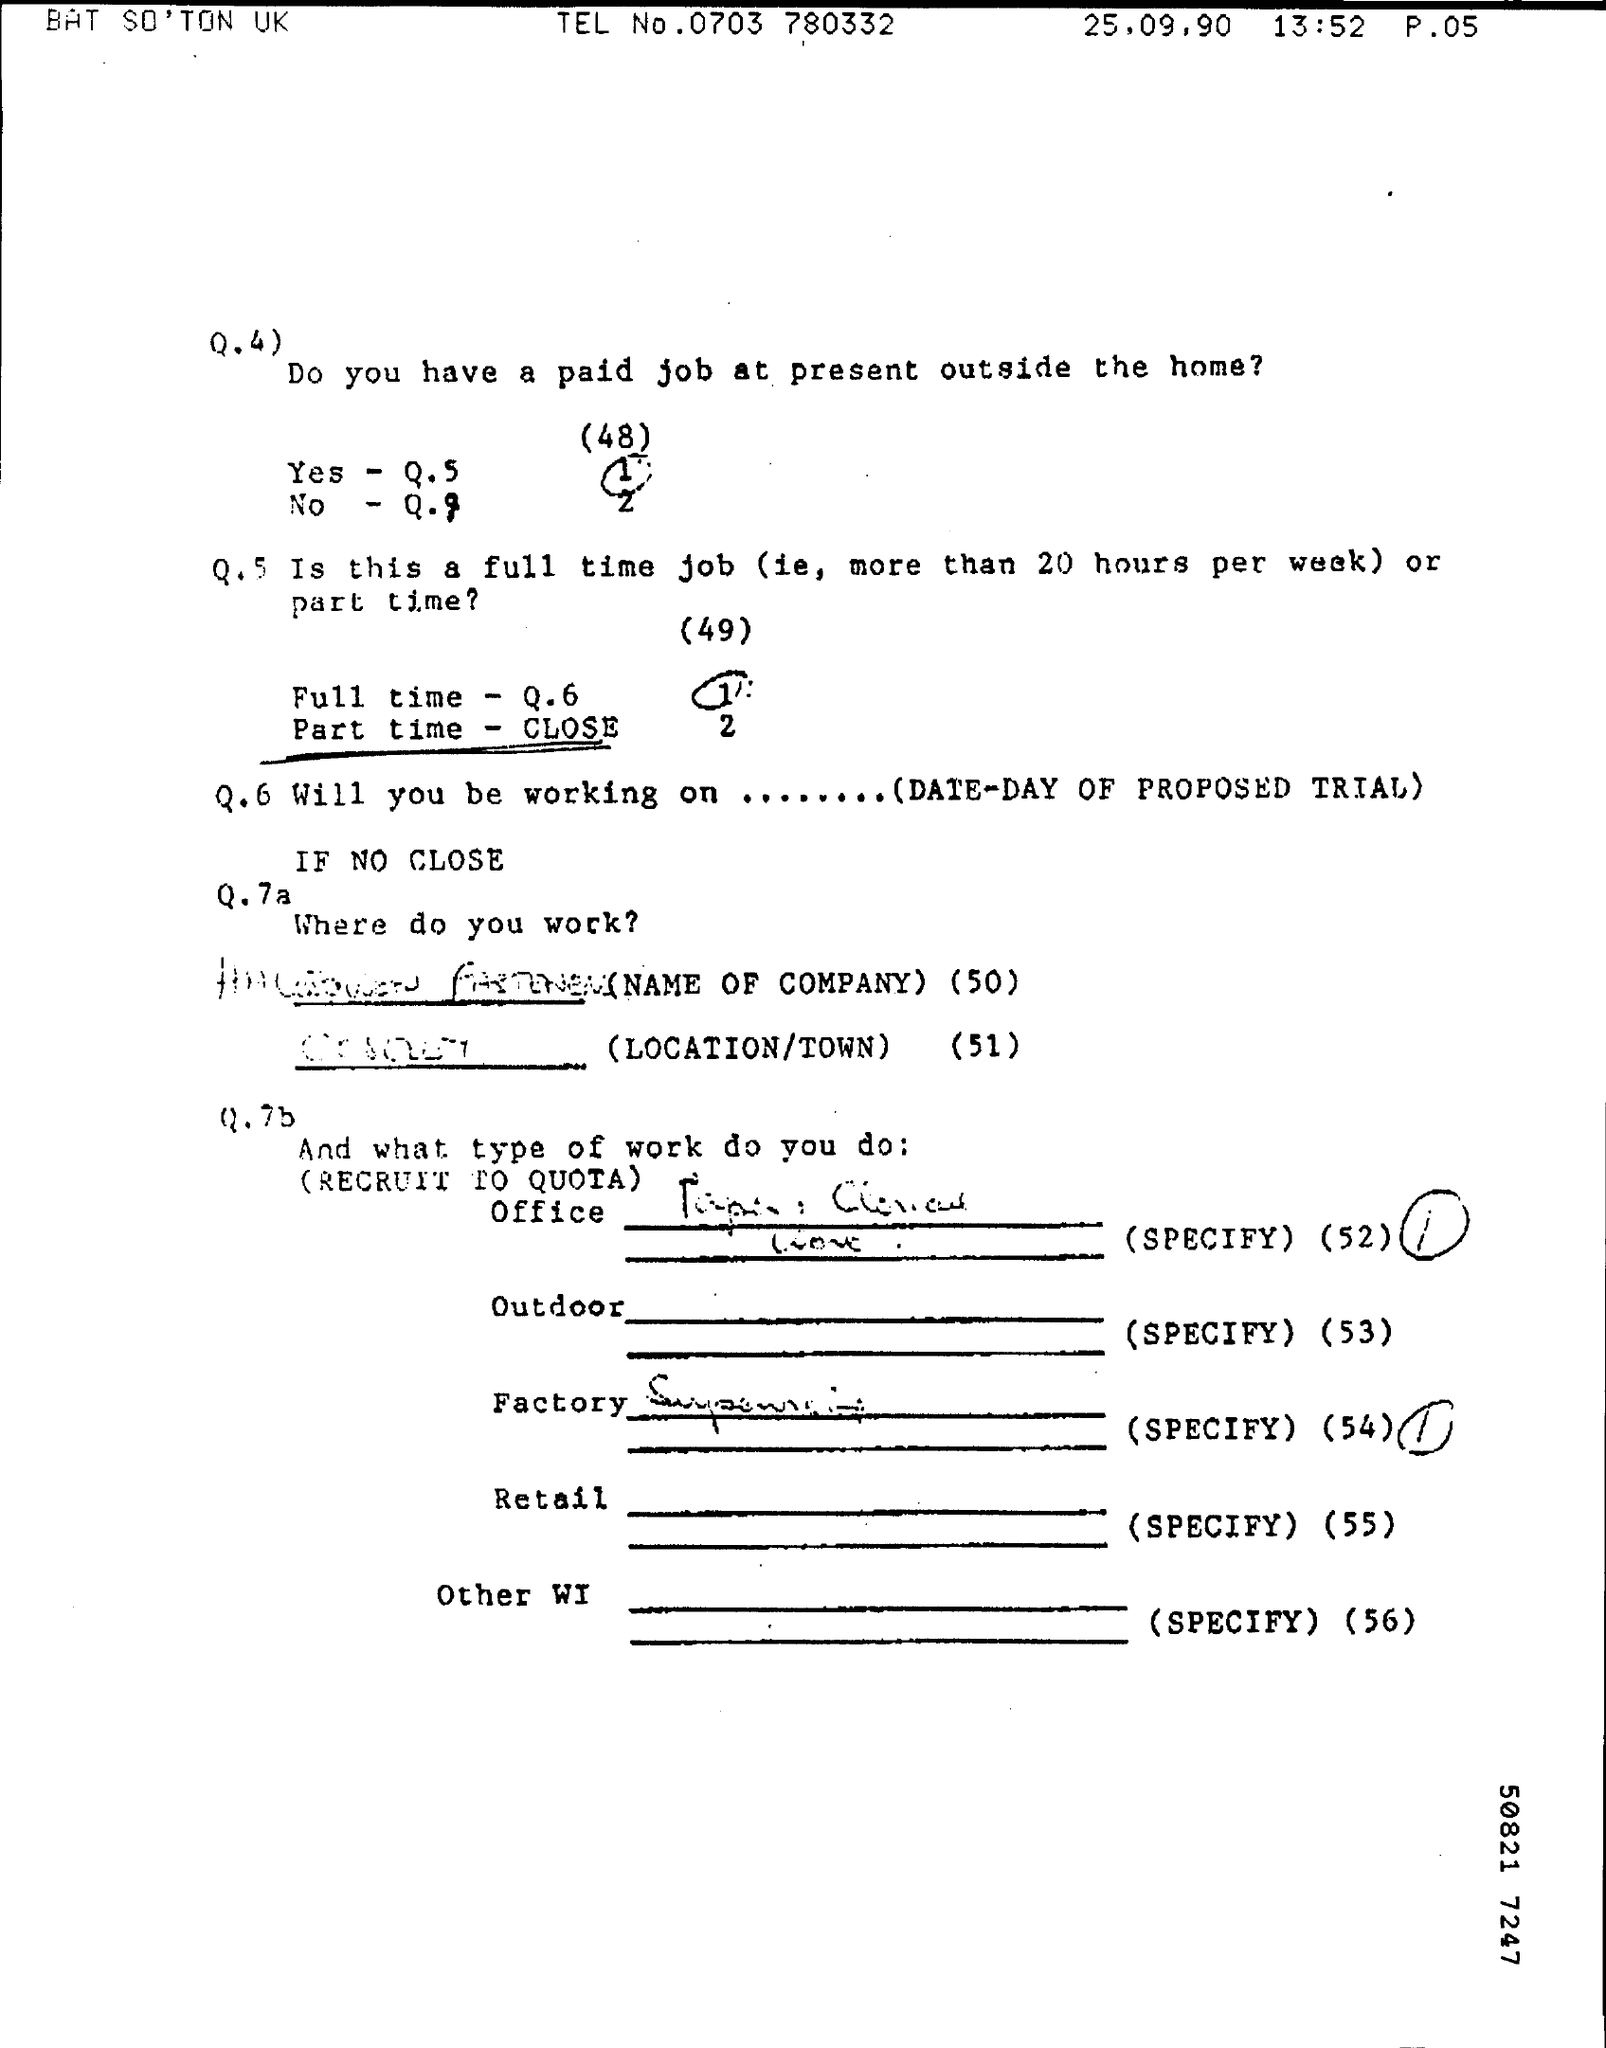Doe the person being asked the questions has a paid job outside the home?
Provide a short and direct response. Yes. 